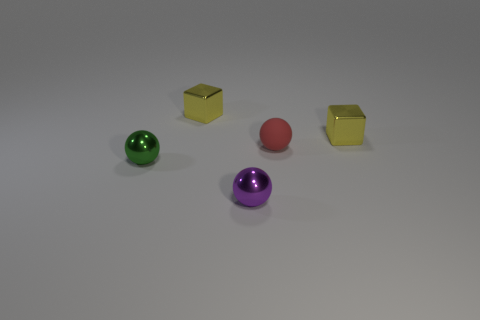Subtract all small metallic spheres. How many spheres are left? 1 Subtract all balls. How many objects are left? 2 Add 1 metal objects. How many objects exist? 6 Subtract 1 cubes. How many cubes are left? 1 Subtract all green balls. How many balls are left? 2 Subtract all blue spheres. Subtract all yellow cylinders. How many spheres are left? 3 Subtract all gray cylinders. How many purple balls are left? 1 Subtract all big yellow objects. Subtract all green spheres. How many objects are left? 4 Add 5 metal balls. How many metal balls are left? 7 Add 1 tiny green things. How many tiny green things exist? 2 